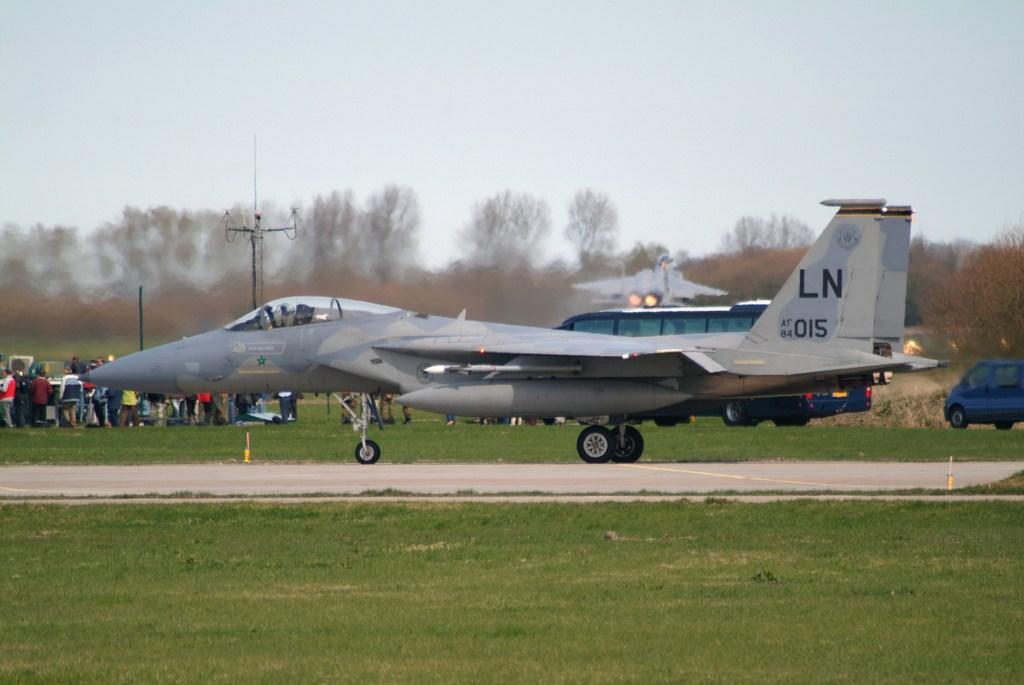What is this jets id number?
Give a very brief answer. 015. 